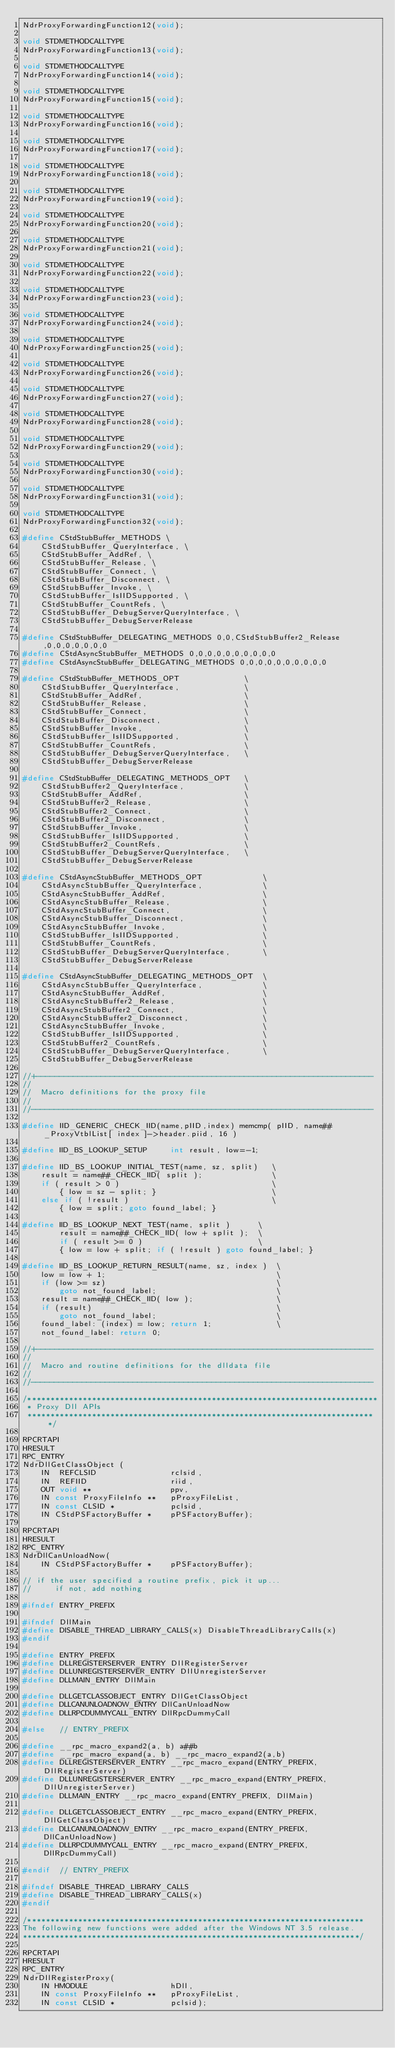Convert code to text. <code><loc_0><loc_0><loc_500><loc_500><_C_>NdrProxyForwardingFunction12(void);

void STDMETHODCALLTYPE
NdrProxyForwardingFunction13(void);

void STDMETHODCALLTYPE
NdrProxyForwardingFunction14(void);

void STDMETHODCALLTYPE
NdrProxyForwardingFunction15(void);

void STDMETHODCALLTYPE
NdrProxyForwardingFunction16(void);

void STDMETHODCALLTYPE
NdrProxyForwardingFunction17(void);

void STDMETHODCALLTYPE
NdrProxyForwardingFunction18(void);

void STDMETHODCALLTYPE
NdrProxyForwardingFunction19(void);

void STDMETHODCALLTYPE
NdrProxyForwardingFunction20(void);

void STDMETHODCALLTYPE
NdrProxyForwardingFunction21(void);

void STDMETHODCALLTYPE
NdrProxyForwardingFunction22(void);

void STDMETHODCALLTYPE
NdrProxyForwardingFunction23(void);

void STDMETHODCALLTYPE
NdrProxyForwardingFunction24(void);

void STDMETHODCALLTYPE
NdrProxyForwardingFunction25(void);

void STDMETHODCALLTYPE
NdrProxyForwardingFunction26(void);

void STDMETHODCALLTYPE
NdrProxyForwardingFunction27(void);

void STDMETHODCALLTYPE
NdrProxyForwardingFunction28(void);

void STDMETHODCALLTYPE
NdrProxyForwardingFunction29(void);

void STDMETHODCALLTYPE
NdrProxyForwardingFunction30(void);

void STDMETHODCALLTYPE
NdrProxyForwardingFunction31(void);

void STDMETHODCALLTYPE
NdrProxyForwardingFunction32(void);

#define CStdStubBuffer_METHODS \
    CStdStubBuffer_QueryInterface, \
    CStdStubBuffer_AddRef, \
    CStdStubBuffer_Release, \
    CStdStubBuffer_Connect, \
    CStdStubBuffer_Disconnect, \
    CStdStubBuffer_Invoke, \
    CStdStubBuffer_IsIIDSupported, \
    CStdStubBuffer_CountRefs, \
    CStdStubBuffer_DebugServerQueryInterface, \
    CStdStubBuffer_DebugServerRelease

#define CStdStubBuffer_DELEGATING_METHODS 0,0,CStdStubBuffer2_Release,0,0,0,0,0,0,0
#define CStdAsyncStubBuffer_METHODS 0,0,0,0,0,0,0,0,0,0
#define CStdAsyncStubBuffer_DELEGATING_METHODS 0,0,0,0,0,0,0,0,0,0

#define CStdStubBuffer_METHODS_OPT              \
    CStdStubBuffer_QueryInterface,              \
    CStdStubBuffer_AddRef,                      \
    CStdStubBuffer_Release,                     \
    CStdStubBuffer_Connect,                     \
    CStdStubBuffer_Disconnect,                  \
    CStdStubBuffer_Invoke,                      \
    CStdStubBuffer_IsIIDSupported,              \
    CStdStubBuffer_CountRefs,                   \
    CStdStubBuffer_DebugServerQueryInterface,   \
    CStdStubBuffer_DebugServerRelease

#define CStdStubBuffer_DELEGATING_METHODS_OPT   \
    CStdStubBuffer2_QueryInterface,             \
    CStdStubBuffer_AddRef,                      \
    CStdStubBuffer2_Release,                    \
    CStdStubBuffer2_Connect,                    \
    CStdStubBuffer2_Disconnect,                 \
    CStdStubBuffer_Invoke,                      \
    CStdStubBuffer_IsIIDSupported,              \
    CStdStubBuffer2_CountRefs,                  \
    CStdStubBuffer_DebugServerQueryInterface,   \
    CStdStubBuffer_DebugServerRelease

#define CStdAsyncStubBuffer_METHODS_OPT             \
    CStdAsyncStubBuffer_QueryInterface,             \
    CStdAsyncStubBuffer_AddRef,                     \
    CStdAsyncStubBuffer_Release,                    \
    CStdAsyncStubBuffer_Connect,                    \
    CStdAsyncStubBuffer_Disconnect,                 \
    CStdAsyncStubBuffer_Invoke,                     \
    CStdStubBuffer_IsIIDSupported,                  \
    CStdStubBuffer_CountRefs,                       \
    CStdStubBuffer_DebugServerQueryInterface,       \
    CStdStubBuffer_DebugServerRelease

#define CStdAsyncStubBuffer_DELEGATING_METHODS_OPT  \
    CStdAsyncStubBuffer_QueryInterface,             \
    CStdAsyncStubBuffer_AddRef,                     \
    CStdAsyncStubBuffer2_Release,                   \
    CStdAsyncStubBuffer2_Connect,                   \
    CStdAsyncStubBuffer2_Disconnect,                \
    CStdAsyncStubBuffer_Invoke,                     \
    CStdStubBuffer_IsIIDSupported,                  \
    CStdStubBuffer2_CountRefs,                      \
    CStdStubBuffer_DebugServerQueryInterface,       \
    CStdStubBuffer_DebugServerRelease

//+-------------------------------------------------------------------------
//
//  Macro definitions for the proxy file
//
//--------------------------------------------------------------------------

#define IID_GENERIC_CHECK_IID(name,pIID,index) memcmp( pIID, name##_ProxyVtblList[ index ]->header.piid, 16 )

#define IID_BS_LOOKUP_SETUP     int result, low=-1;

#define IID_BS_LOOKUP_INITIAL_TEST(name, sz, split)   \
    result = name##_CHECK_IID( split );               \
    if ( result > 0 )                                 \
        { low = sz - split; }                         \
    else if ( !result )                               \
        { low = split; goto found_label; }

#define IID_BS_LOOKUP_NEXT_TEST(name, split )      \
        result = name##_CHECK_IID( low + split );  \
        if ( result >= 0 )                         \
        { low = low + split; if ( !result ) goto found_label; }

#define IID_BS_LOOKUP_RETURN_RESULT(name, sz, index )  \
    low = low + 1;                                     \
    if (low >= sz)                                     \
        goto not_found_label;                          \
    result = name##_CHECK_IID( low );                  \
    if (result)                                        \
        goto not_found_label;                          \
    found_label: (index) = low; return 1;              \
    not_found_label: return 0;

//+-------------------------------------------------------------------------
//
//  Macro and routine definitions for the dlldata file
//
//--------------------------------------------------------------------------

/****************************************************************************
 * Proxy Dll APIs
 ****************************************************************************/

RPCRTAPI
HRESULT
RPC_ENTRY
NdrDllGetClassObject (
    IN  REFCLSID                rclsid,
    IN  REFIID                  riid,
    OUT void **                 ppv,
    IN const ProxyFileInfo **   pProxyFileList,
    IN const CLSID *            pclsid,
    IN CStdPSFactoryBuffer *    pPSFactoryBuffer);

RPCRTAPI
HRESULT
RPC_ENTRY
NdrDllCanUnloadNow(
    IN CStdPSFactoryBuffer *    pPSFactoryBuffer);

// if the user specified a routine prefix, pick it up...
//     if not, add nothing

#ifndef ENTRY_PREFIX

#ifndef DllMain
#define DISABLE_THREAD_LIBRARY_CALLS(x) DisableThreadLibraryCalls(x)
#endif

#define ENTRY_PREFIX
#define DLLREGISTERSERVER_ENTRY DllRegisterServer
#define DLLUNREGISTERSERVER_ENTRY DllUnregisterServer
#define DLLMAIN_ENTRY DllMain

#define DLLGETCLASSOBJECT_ENTRY DllGetClassObject
#define DLLCANUNLOADNOW_ENTRY DllCanUnloadNow
#define DLLRPCDUMMYCALL_ENTRY DllRpcDummyCall

#else   // ENTRY_PREFIX

#define __rpc_macro_expand2(a, b) a##b
#define __rpc_macro_expand(a, b) __rpc_macro_expand2(a,b)
#define DLLREGISTERSERVER_ENTRY __rpc_macro_expand(ENTRY_PREFIX, DllRegisterServer)
#define DLLUNREGISTERSERVER_ENTRY __rpc_macro_expand(ENTRY_PREFIX, DllUnregisterServer)
#define DLLMAIN_ENTRY __rpc_macro_expand(ENTRY_PREFIX, DllMain)

#define DLLGETCLASSOBJECT_ENTRY __rpc_macro_expand(ENTRY_PREFIX, DllGetClassObject)
#define DLLCANUNLOADNOW_ENTRY __rpc_macro_expand(ENTRY_PREFIX, DllCanUnloadNow)
#define DLLRPCDUMMYCALL_ENTRY __rpc_macro_expand(ENTRY_PREFIX, DllRpcDummyCall)

#endif  // ENTRY_PREFIX

#ifndef DISABLE_THREAD_LIBRARY_CALLS
#define DISABLE_THREAD_LIBRARY_CALLS(x)
#endif

/*************************************************************************
The following new functions were added after the Windows NT 3.5 release.
*************************************************************************/

RPCRTAPI
HRESULT
RPC_ENTRY
NdrDllRegisterProxy(
    IN HMODULE                  hDll,
    IN const ProxyFileInfo **   pProxyFileList,
    IN const CLSID *            pclsid);
</code> 